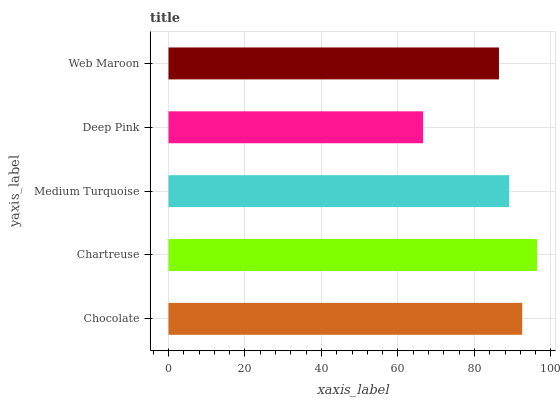Is Deep Pink the minimum?
Answer yes or no. Yes. Is Chartreuse the maximum?
Answer yes or no. Yes. Is Medium Turquoise the minimum?
Answer yes or no. No. Is Medium Turquoise the maximum?
Answer yes or no. No. Is Chartreuse greater than Medium Turquoise?
Answer yes or no. Yes. Is Medium Turquoise less than Chartreuse?
Answer yes or no. Yes. Is Medium Turquoise greater than Chartreuse?
Answer yes or no. No. Is Chartreuse less than Medium Turquoise?
Answer yes or no. No. Is Medium Turquoise the high median?
Answer yes or no. Yes. Is Medium Turquoise the low median?
Answer yes or no. Yes. Is Deep Pink the high median?
Answer yes or no. No. Is Deep Pink the low median?
Answer yes or no. No. 